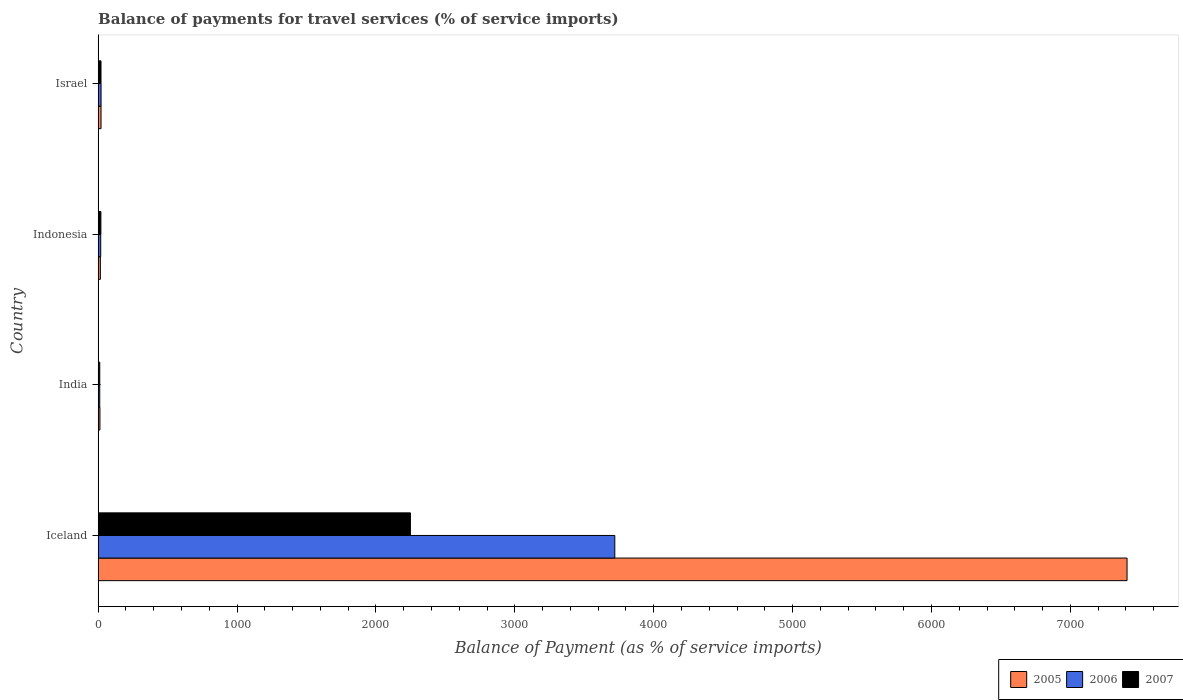How many different coloured bars are there?
Offer a terse response. 3. How many groups of bars are there?
Give a very brief answer. 4. Are the number of bars per tick equal to the number of legend labels?
Your response must be concise. Yes. How many bars are there on the 2nd tick from the top?
Your answer should be very brief. 3. What is the label of the 2nd group of bars from the top?
Make the answer very short. Indonesia. In how many cases, is the number of bars for a given country not equal to the number of legend labels?
Offer a terse response. 0. What is the balance of payments for travel services in 2006 in Israel?
Provide a short and direct response. 21.19. Across all countries, what is the maximum balance of payments for travel services in 2005?
Your answer should be very brief. 7408.18. Across all countries, what is the minimum balance of payments for travel services in 2007?
Keep it short and to the point. 11.71. In which country was the balance of payments for travel services in 2006 maximum?
Keep it short and to the point. Iceland. In which country was the balance of payments for travel services in 2006 minimum?
Give a very brief answer. India. What is the total balance of payments for travel services in 2006 in the graph?
Offer a terse response. 3771.62. What is the difference between the balance of payments for travel services in 2005 in Indonesia and that in Israel?
Your answer should be very brief. -4.79. What is the difference between the balance of payments for travel services in 2005 in Israel and the balance of payments for travel services in 2006 in India?
Give a very brief answer. 9.24. What is the average balance of payments for travel services in 2006 per country?
Your answer should be compact. 942.9. What is the difference between the balance of payments for travel services in 2005 and balance of payments for travel services in 2007 in Israel?
Your answer should be very brief. 0.18. In how many countries, is the balance of payments for travel services in 2006 greater than 2800 %?
Provide a succinct answer. 1. What is the ratio of the balance of payments for travel services in 2005 in India to that in Israel?
Give a very brief answer. 0.63. Is the difference between the balance of payments for travel services in 2005 in India and Indonesia greater than the difference between the balance of payments for travel services in 2007 in India and Indonesia?
Give a very brief answer. Yes. What is the difference between the highest and the second highest balance of payments for travel services in 2007?
Your answer should be very brief. 2227.67. What is the difference between the highest and the lowest balance of payments for travel services in 2006?
Provide a short and direct response. 3708.34. In how many countries, is the balance of payments for travel services in 2006 greater than the average balance of payments for travel services in 2006 taken over all countries?
Your answer should be compact. 1. Is the sum of the balance of payments for travel services in 2006 in Iceland and Israel greater than the maximum balance of payments for travel services in 2005 across all countries?
Provide a short and direct response. No. What does the 1st bar from the top in Indonesia represents?
Offer a very short reply. 2007. What does the 2nd bar from the bottom in India represents?
Provide a succinct answer. 2006. How many countries are there in the graph?
Your answer should be very brief. 4. What is the difference between two consecutive major ticks on the X-axis?
Provide a short and direct response. 1000. Does the graph contain any zero values?
Ensure brevity in your answer.  No. Does the graph contain grids?
Give a very brief answer. No. Where does the legend appear in the graph?
Make the answer very short. Bottom right. How are the legend labels stacked?
Provide a short and direct response. Horizontal. What is the title of the graph?
Offer a terse response. Balance of payments for travel services (% of service imports). What is the label or title of the X-axis?
Offer a very short reply. Balance of Payment (as % of service imports). What is the Balance of Payment (as % of service imports) of 2005 in Iceland?
Ensure brevity in your answer.  7408.18. What is the Balance of Payment (as % of service imports) in 2006 in Iceland?
Offer a terse response. 3720.04. What is the Balance of Payment (as % of service imports) of 2007 in Iceland?
Offer a very short reply. 2248.42. What is the Balance of Payment (as % of service imports) of 2005 in India?
Keep it short and to the point. 13.12. What is the Balance of Payment (as % of service imports) in 2006 in India?
Offer a very short reply. 11.7. What is the Balance of Payment (as % of service imports) in 2007 in India?
Offer a very short reply. 11.71. What is the Balance of Payment (as % of service imports) in 2005 in Indonesia?
Your response must be concise. 16.15. What is the Balance of Payment (as % of service imports) in 2006 in Indonesia?
Keep it short and to the point. 18.69. What is the Balance of Payment (as % of service imports) in 2007 in Indonesia?
Offer a very short reply. 19.95. What is the Balance of Payment (as % of service imports) of 2005 in Israel?
Make the answer very short. 20.94. What is the Balance of Payment (as % of service imports) in 2006 in Israel?
Give a very brief answer. 21.19. What is the Balance of Payment (as % of service imports) in 2007 in Israel?
Give a very brief answer. 20.76. Across all countries, what is the maximum Balance of Payment (as % of service imports) of 2005?
Offer a terse response. 7408.18. Across all countries, what is the maximum Balance of Payment (as % of service imports) in 2006?
Make the answer very short. 3720.04. Across all countries, what is the maximum Balance of Payment (as % of service imports) of 2007?
Offer a terse response. 2248.42. Across all countries, what is the minimum Balance of Payment (as % of service imports) of 2005?
Ensure brevity in your answer.  13.12. Across all countries, what is the minimum Balance of Payment (as % of service imports) in 2006?
Make the answer very short. 11.7. Across all countries, what is the minimum Balance of Payment (as % of service imports) of 2007?
Provide a short and direct response. 11.71. What is the total Balance of Payment (as % of service imports) of 2005 in the graph?
Your answer should be very brief. 7458.39. What is the total Balance of Payment (as % of service imports) in 2006 in the graph?
Make the answer very short. 3771.62. What is the total Balance of Payment (as % of service imports) in 2007 in the graph?
Your answer should be compact. 2300.85. What is the difference between the Balance of Payment (as % of service imports) in 2005 in Iceland and that in India?
Ensure brevity in your answer.  7395.07. What is the difference between the Balance of Payment (as % of service imports) of 2006 in Iceland and that in India?
Offer a very short reply. 3708.34. What is the difference between the Balance of Payment (as % of service imports) of 2007 in Iceland and that in India?
Offer a terse response. 2236.71. What is the difference between the Balance of Payment (as % of service imports) of 2005 in Iceland and that in Indonesia?
Provide a succinct answer. 7392.04. What is the difference between the Balance of Payment (as % of service imports) in 2006 in Iceland and that in Indonesia?
Ensure brevity in your answer.  3701.35. What is the difference between the Balance of Payment (as % of service imports) in 2007 in Iceland and that in Indonesia?
Your response must be concise. 2228.47. What is the difference between the Balance of Payment (as % of service imports) in 2005 in Iceland and that in Israel?
Give a very brief answer. 7387.25. What is the difference between the Balance of Payment (as % of service imports) in 2006 in Iceland and that in Israel?
Offer a very short reply. 3698.86. What is the difference between the Balance of Payment (as % of service imports) in 2007 in Iceland and that in Israel?
Your answer should be compact. 2227.67. What is the difference between the Balance of Payment (as % of service imports) of 2005 in India and that in Indonesia?
Keep it short and to the point. -3.03. What is the difference between the Balance of Payment (as % of service imports) in 2006 in India and that in Indonesia?
Make the answer very short. -7. What is the difference between the Balance of Payment (as % of service imports) in 2007 in India and that in Indonesia?
Offer a terse response. -8.24. What is the difference between the Balance of Payment (as % of service imports) of 2005 in India and that in Israel?
Give a very brief answer. -7.82. What is the difference between the Balance of Payment (as % of service imports) of 2006 in India and that in Israel?
Provide a short and direct response. -9.49. What is the difference between the Balance of Payment (as % of service imports) in 2007 in India and that in Israel?
Offer a terse response. -9.05. What is the difference between the Balance of Payment (as % of service imports) of 2005 in Indonesia and that in Israel?
Your answer should be very brief. -4.79. What is the difference between the Balance of Payment (as % of service imports) in 2006 in Indonesia and that in Israel?
Offer a terse response. -2.49. What is the difference between the Balance of Payment (as % of service imports) of 2007 in Indonesia and that in Israel?
Your response must be concise. -0.81. What is the difference between the Balance of Payment (as % of service imports) of 2005 in Iceland and the Balance of Payment (as % of service imports) of 2006 in India?
Provide a short and direct response. 7396.49. What is the difference between the Balance of Payment (as % of service imports) in 2005 in Iceland and the Balance of Payment (as % of service imports) in 2007 in India?
Ensure brevity in your answer.  7396.47. What is the difference between the Balance of Payment (as % of service imports) of 2006 in Iceland and the Balance of Payment (as % of service imports) of 2007 in India?
Provide a short and direct response. 3708.33. What is the difference between the Balance of Payment (as % of service imports) in 2005 in Iceland and the Balance of Payment (as % of service imports) in 2006 in Indonesia?
Your response must be concise. 7389.49. What is the difference between the Balance of Payment (as % of service imports) in 2005 in Iceland and the Balance of Payment (as % of service imports) in 2007 in Indonesia?
Give a very brief answer. 7388.23. What is the difference between the Balance of Payment (as % of service imports) of 2006 in Iceland and the Balance of Payment (as % of service imports) of 2007 in Indonesia?
Provide a succinct answer. 3700.09. What is the difference between the Balance of Payment (as % of service imports) of 2005 in Iceland and the Balance of Payment (as % of service imports) of 2006 in Israel?
Keep it short and to the point. 7387. What is the difference between the Balance of Payment (as % of service imports) in 2005 in Iceland and the Balance of Payment (as % of service imports) in 2007 in Israel?
Make the answer very short. 7387.43. What is the difference between the Balance of Payment (as % of service imports) of 2006 in Iceland and the Balance of Payment (as % of service imports) of 2007 in Israel?
Give a very brief answer. 3699.28. What is the difference between the Balance of Payment (as % of service imports) of 2005 in India and the Balance of Payment (as % of service imports) of 2006 in Indonesia?
Your answer should be very brief. -5.58. What is the difference between the Balance of Payment (as % of service imports) of 2005 in India and the Balance of Payment (as % of service imports) of 2007 in Indonesia?
Ensure brevity in your answer.  -6.84. What is the difference between the Balance of Payment (as % of service imports) of 2006 in India and the Balance of Payment (as % of service imports) of 2007 in Indonesia?
Your answer should be compact. -8.25. What is the difference between the Balance of Payment (as % of service imports) of 2005 in India and the Balance of Payment (as % of service imports) of 2006 in Israel?
Offer a very short reply. -8.07. What is the difference between the Balance of Payment (as % of service imports) of 2005 in India and the Balance of Payment (as % of service imports) of 2007 in Israel?
Keep it short and to the point. -7.64. What is the difference between the Balance of Payment (as % of service imports) in 2006 in India and the Balance of Payment (as % of service imports) in 2007 in Israel?
Offer a terse response. -9.06. What is the difference between the Balance of Payment (as % of service imports) of 2005 in Indonesia and the Balance of Payment (as % of service imports) of 2006 in Israel?
Your answer should be very brief. -5.04. What is the difference between the Balance of Payment (as % of service imports) in 2005 in Indonesia and the Balance of Payment (as % of service imports) in 2007 in Israel?
Ensure brevity in your answer.  -4.61. What is the difference between the Balance of Payment (as % of service imports) in 2006 in Indonesia and the Balance of Payment (as % of service imports) in 2007 in Israel?
Provide a short and direct response. -2.06. What is the average Balance of Payment (as % of service imports) of 2005 per country?
Your response must be concise. 1864.6. What is the average Balance of Payment (as % of service imports) of 2006 per country?
Ensure brevity in your answer.  942.9. What is the average Balance of Payment (as % of service imports) of 2007 per country?
Provide a short and direct response. 575.21. What is the difference between the Balance of Payment (as % of service imports) of 2005 and Balance of Payment (as % of service imports) of 2006 in Iceland?
Your answer should be compact. 3688.14. What is the difference between the Balance of Payment (as % of service imports) of 2005 and Balance of Payment (as % of service imports) of 2007 in Iceland?
Keep it short and to the point. 5159.76. What is the difference between the Balance of Payment (as % of service imports) of 2006 and Balance of Payment (as % of service imports) of 2007 in Iceland?
Your answer should be compact. 1471.62. What is the difference between the Balance of Payment (as % of service imports) in 2005 and Balance of Payment (as % of service imports) in 2006 in India?
Your answer should be very brief. 1.42. What is the difference between the Balance of Payment (as % of service imports) of 2005 and Balance of Payment (as % of service imports) of 2007 in India?
Ensure brevity in your answer.  1.4. What is the difference between the Balance of Payment (as % of service imports) of 2006 and Balance of Payment (as % of service imports) of 2007 in India?
Make the answer very short. -0.01. What is the difference between the Balance of Payment (as % of service imports) in 2005 and Balance of Payment (as % of service imports) in 2006 in Indonesia?
Provide a short and direct response. -2.55. What is the difference between the Balance of Payment (as % of service imports) of 2005 and Balance of Payment (as % of service imports) of 2007 in Indonesia?
Offer a very short reply. -3.8. What is the difference between the Balance of Payment (as % of service imports) of 2006 and Balance of Payment (as % of service imports) of 2007 in Indonesia?
Your answer should be compact. -1.26. What is the difference between the Balance of Payment (as % of service imports) of 2005 and Balance of Payment (as % of service imports) of 2006 in Israel?
Keep it short and to the point. -0.25. What is the difference between the Balance of Payment (as % of service imports) of 2005 and Balance of Payment (as % of service imports) of 2007 in Israel?
Your answer should be very brief. 0.18. What is the difference between the Balance of Payment (as % of service imports) of 2006 and Balance of Payment (as % of service imports) of 2007 in Israel?
Give a very brief answer. 0.43. What is the ratio of the Balance of Payment (as % of service imports) of 2005 in Iceland to that in India?
Your answer should be compact. 564.79. What is the ratio of the Balance of Payment (as % of service imports) of 2006 in Iceland to that in India?
Make the answer very short. 318.01. What is the ratio of the Balance of Payment (as % of service imports) of 2007 in Iceland to that in India?
Ensure brevity in your answer.  191.97. What is the ratio of the Balance of Payment (as % of service imports) in 2005 in Iceland to that in Indonesia?
Give a very brief answer. 458.78. What is the ratio of the Balance of Payment (as % of service imports) in 2006 in Iceland to that in Indonesia?
Give a very brief answer. 199. What is the ratio of the Balance of Payment (as % of service imports) in 2007 in Iceland to that in Indonesia?
Offer a very short reply. 112.69. What is the ratio of the Balance of Payment (as % of service imports) of 2005 in Iceland to that in Israel?
Ensure brevity in your answer.  353.8. What is the ratio of the Balance of Payment (as % of service imports) of 2006 in Iceland to that in Israel?
Make the answer very short. 175.59. What is the ratio of the Balance of Payment (as % of service imports) of 2007 in Iceland to that in Israel?
Your answer should be compact. 108.32. What is the ratio of the Balance of Payment (as % of service imports) of 2005 in India to that in Indonesia?
Your answer should be compact. 0.81. What is the ratio of the Balance of Payment (as % of service imports) in 2006 in India to that in Indonesia?
Provide a short and direct response. 0.63. What is the ratio of the Balance of Payment (as % of service imports) in 2007 in India to that in Indonesia?
Give a very brief answer. 0.59. What is the ratio of the Balance of Payment (as % of service imports) of 2005 in India to that in Israel?
Make the answer very short. 0.63. What is the ratio of the Balance of Payment (as % of service imports) of 2006 in India to that in Israel?
Ensure brevity in your answer.  0.55. What is the ratio of the Balance of Payment (as % of service imports) in 2007 in India to that in Israel?
Give a very brief answer. 0.56. What is the ratio of the Balance of Payment (as % of service imports) of 2005 in Indonesia to that in Israel?
Your response must be concise. 0.77. What is the ratio of the Balance of Payment (as % of service imports) of 2006 in Indonesia to that in Israel?
Your answer should be compact. 0.88. What is the ratio of the Balance of Payment (as % of service imports) of 2007 in Indonesia to that in Israel?
Offer a very short reply. 0.96. What is the difference between the highest and the second highest Balance of Payment (as % of service imports) in 2005?
Your answer should be compact. 7387.25. What is the difference between the highest and the second highest Balance of Payment (as % of service imports) in 2006?
Your response must be concise. 3698.86. What is the difference between the highest and the second highest Balance of Payment (as % of service imports) in 2007?
Offer a very short reply. 2227.67. What is the difference between the highest and the lowest Balance of Payment (as % of service imports) of 2005?
Your response must be concise. 7395.07. What is the difference between the highest and the lowest Balance of Payment (as % of service imports) in 2006?
Keep it short and to the point. 3708.34. What is the difference between the highest and the lowest Balance of Payment (as % of service imports) of 2007?
Keep it short and to the point. 2236.71. 